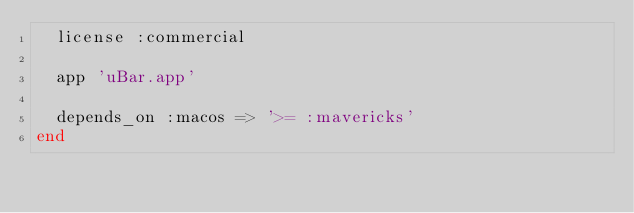Convert code to text. <code><loc_0><loc_0><loc_500><loc_500><_Ruby_>  license :commercial

  app 'uBar.app'

  depends_on :macos => '>= :mavericks'
end
</code> 